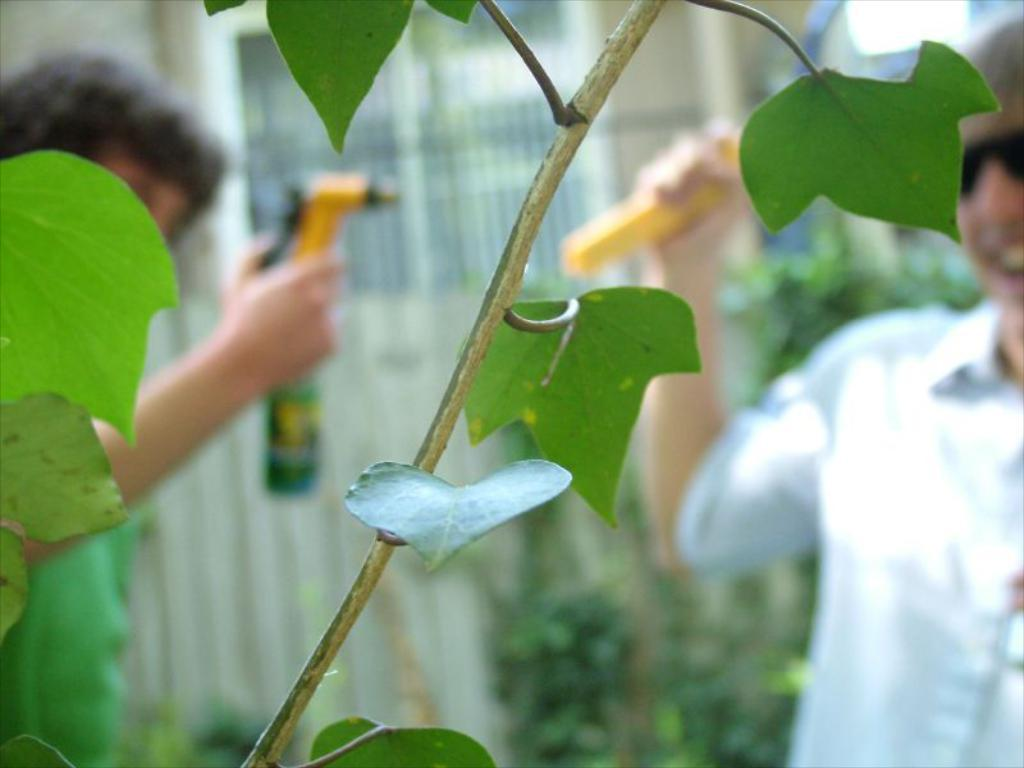What can be seen in the foreground of the image? There are leaves on a stem in the foreground of the image. How many people are in the image? There are two people standing in the image. What are the people holding in their hands? The people are holding objects. Can you describe the background of the image? The background of the image is blurred. What type of fork can be seen in the image? There is no fork present in the image. 